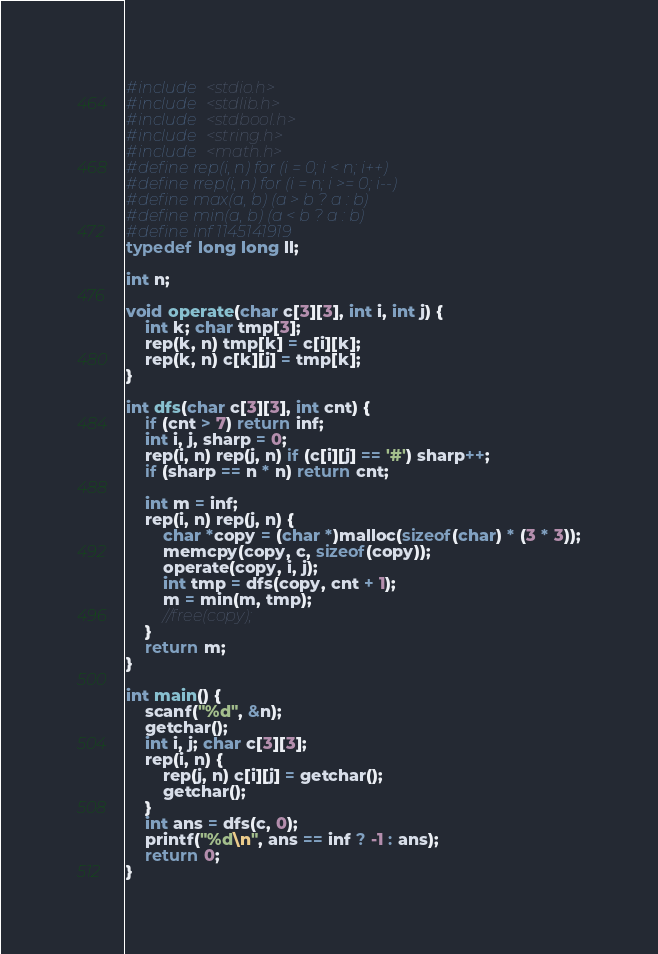<code> <loc_0><loc_0><loc_500><loc_500><_C_>#include <stdio.h>
#include <stdlib.h>
#include <stdbool.h>
#include <string.h>
#include <math.h>
#define rep(i, n) for (i = 0; i < n; i++)
#define rrep(i, n) for (i = n; i >= 0; i--)
#define max(a, b) (a > b ? a : b)
#define min(a, b) (a < b ? a : b)
#define inf 1145141919
typedef long long ll;

int n;

void operate(char c[3][3], int i, int j) {
    int k; char tmp[3];
    rep(k, n) tmp[k] = c[i][k];
    rep(k, n) c[k][j] = tmp[k];
}

int dfs(char c[3][3], int cnt) {
    if (cnt > 7) return inf;
    int i, j, sharp = 0;
    rep(i, n) rep(j, n) if (c[i][j] == '#') sharp++;
    if (sharp == n * n) return cnt;
    
    int m = inf;
    rep(i, n) rep(j, n) {
        char *copy = (char *)malloc(sizeof(char) * (3 * 3));
        memcpy(copy, c, sizeof(copy));
        operate(copy, i, j);
        int tmp = dfs(copy, cnt + 1);
        m = min(m, tmp);
        //free(copy);
    }
    return m;
}

int main() {
    scanf("%d", &n);
    getchar();
    int i, j; char c[3][3];
    rep(i, n) {
        rep(j, n) c[i][j] = getchar();
        getchar();
    }
    int ans = dfs(c, 0);
    printf("%d\n", ans == inf ? -1 : ans);
    return 0;
}</code> 